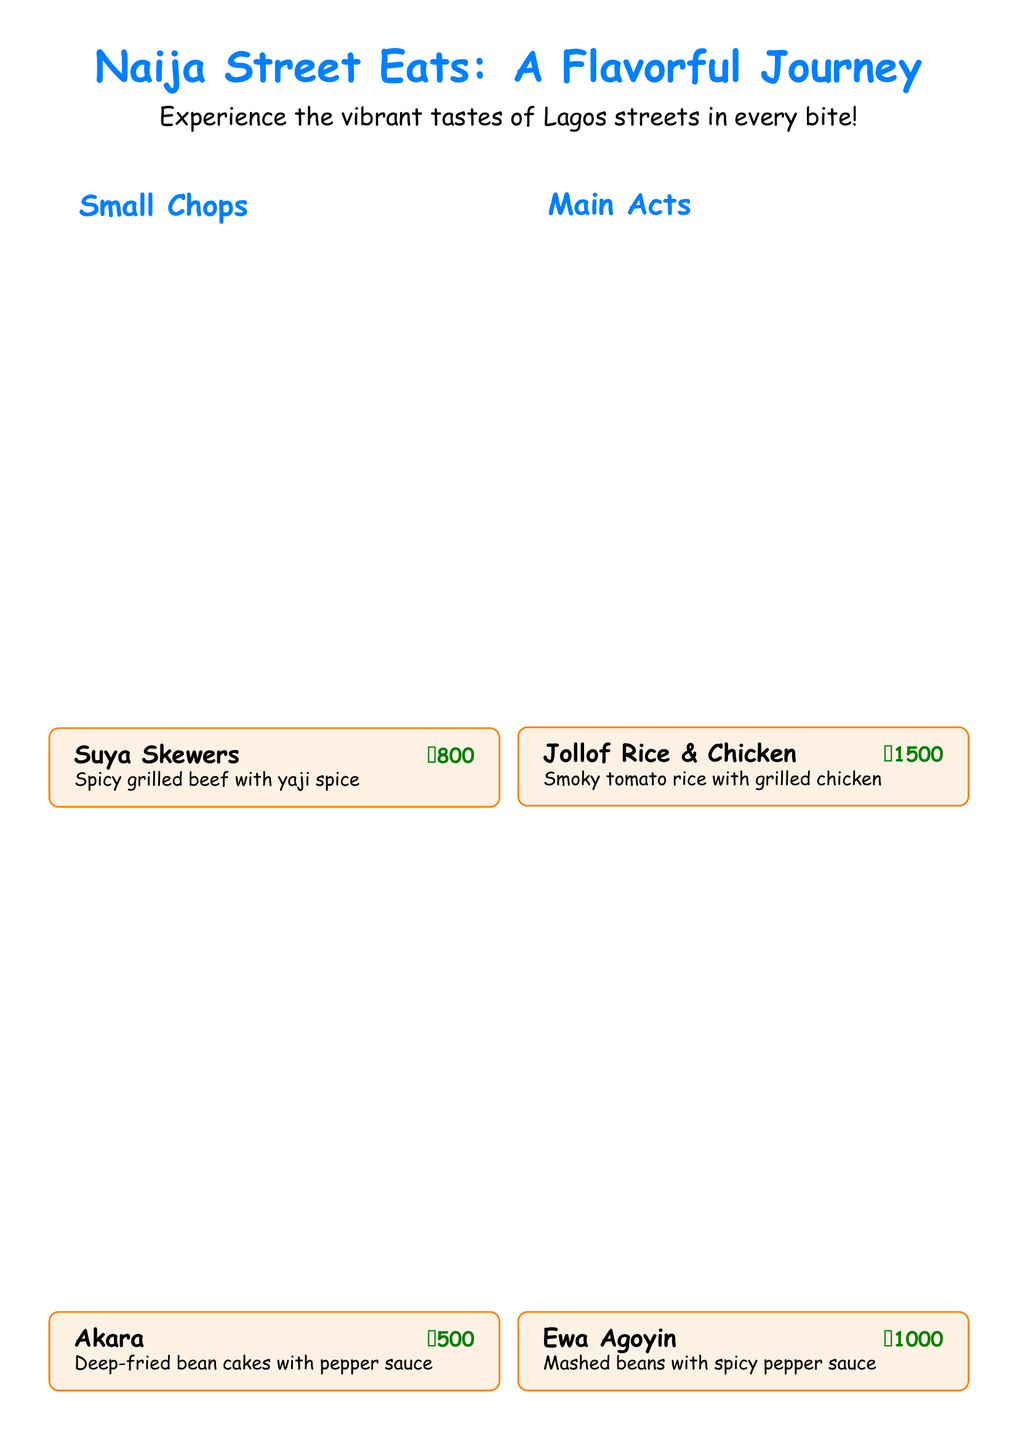What is the title of the menu? The title is prominently displayed at the top of the document, highlighting the theme of the menu.
Answer: Naija Street Eats: A Flavorful Journey How much are Suya Skewers? The price for Suya Skewers is clearly listed next to the dish in the menu section.
Answer: ₦800 What type of drink is Zobo? The drink Zobo is described in the drinks section, indicating its main ingredient and nature.
Answer: Refreshing hibiscus drink What is included in the "Main Acts" section? This section lists the primary dishes offered on the menu distinct from the appetizers and sweets.
Answer: Jollof Rice & Chicken, Ewa Agoyin How much does Puff Puff cost? The menu indicates specific prices for all items, including Puff Puff.
Answer: ₦400 What is the weight or volume of the drink Chapman? The document states the price, but it is a reasoning question about the actual serving details, which are not provided. Thus, the serving size is unknown.
Answer: Unknown How many small chops are listed? By counting the items in the "Small Chops" section, we can determine their number.
Answer: 2 Which item has a price of ₦1000? The price is linked to specific dishes in the menu, thereby allowing for identification of the dish.
Answer: Ewa Agoyin 